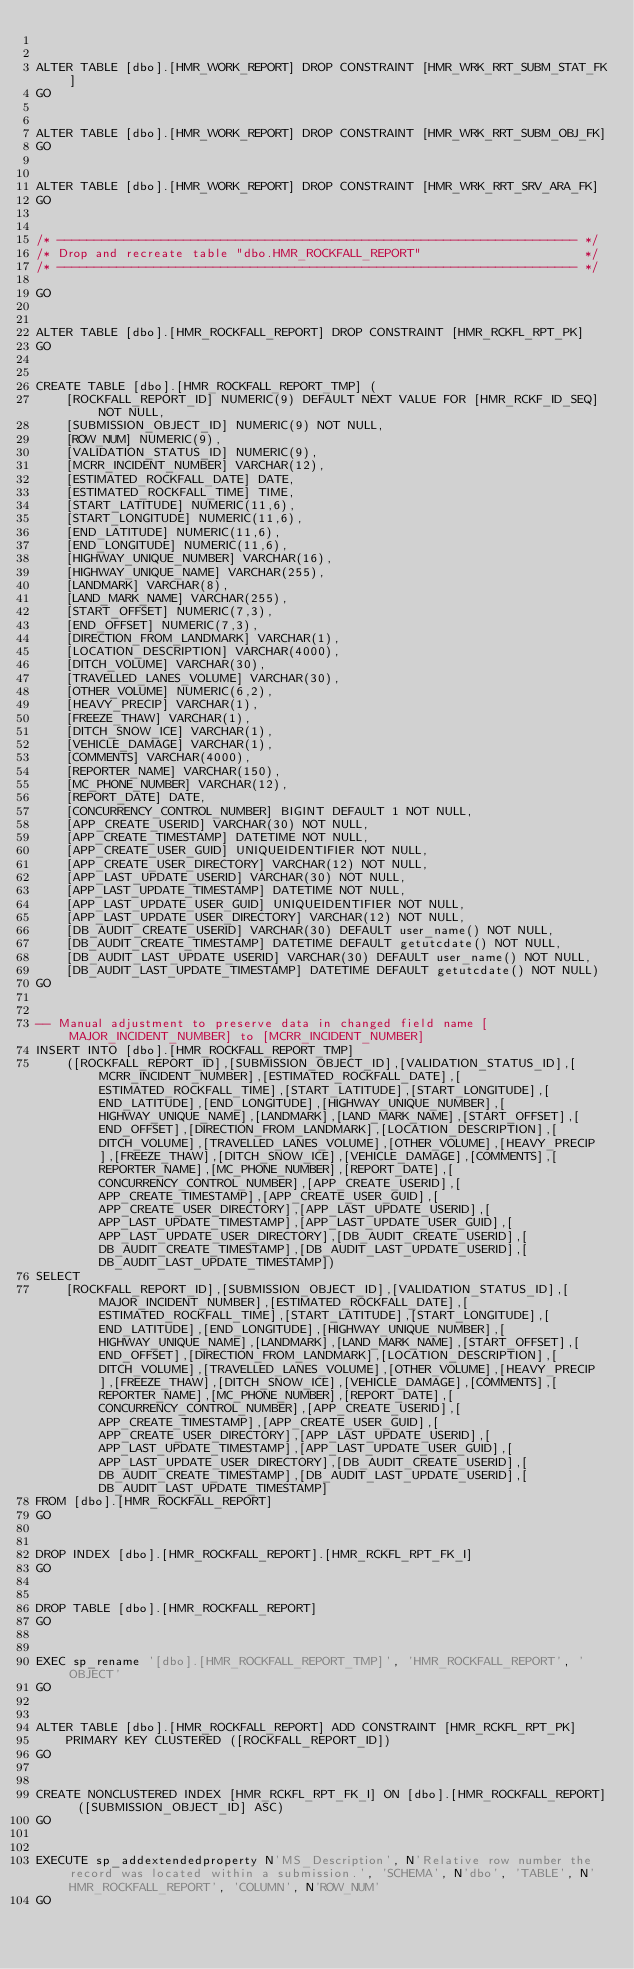<code> <loc_0><loc_0><loc_500><loc_500><_SQL_>

ALTER TABLE [dbo].[HMR_WORK_REPORT] DROP CONSTRAINT [HMR_WRK_RRT_SUBM_STAT_FK]
GO


ALTER TABLE [dbo].[HMR_WORK_REPORT] DROP CONSTRAINT [HMR_WRK_RRT_SUBM_OBJ_FK]
GO


ALTER TABLE [dbo].[HMR_WORK_REPORT] DROP CONSTRAINT [HMR_WRK_RRT_SRV_ARA_FK]
GO


/* ---------------------------------------------------------------------- */
/* Drop and recreate table "dbo.HMR_ROCKFALL_REPORT"                      */
/* ---------------------------------------------------------------------- */

GO


ALTER TABLE [dbo].[HMR_ROCKFALL_REPORT] DROP CONSTRAINT [HMR_RCKFL_RPT_PK]
GO


CREATE TABLE [dbo].[HMR_ROCKFALL_REPORT_TMP] (
    [ROCKFALL_REPORT_ID] NUMERIC(9) DEFAULT NEXT VALUE FOR [HMR_RCKF_ID_SEQ] NOT NULL,
    [SUBMISSION_OBJECT_ID] NUMERIC(9) NOT NULL,
    [ROW_NUM] NUMERIC(9),
    [VALIDATION_STATUS_ID] NUMERIC(9),
    [MCRR_INCIDENT_NUMBER] VARCHAR(12),
    [ESTIMATED_ROCKFALL_DATE] DATE,
    [ESTIMATED_ROCKFALL_TIME] TIME,
    [START_LATITUDE] NUMERIC(11,6),
    [START_LONGITUDE] NUMERIC(11,6),
    [END_LATITUDE] NUMERIC(11,6),
    [END_LONGITUDE] NUMERIC(11,6),
    [HIGHWAY_UNIQUE_NUMBER] VARCHAR(16),
    [HIGHWAY_UNIQUE_NAME] VARCHAR(255),
    [LANDMARK] VARCHAR(8),
    [LAND_MARK_NAME] VARCHAR(255),
    [START_OFFSET] NUMERIC(7,3),
    [END_OFFSET] NUMERIC(7,3),
    [DIRECTION_FROM_LANDMARK] VARCHAR(1),
    [LOCATION_DESCRIPTION] VARCHAR(4000),
    [DITCH_VOLUME] VARCHAR(30),
    [TRAVELLED_LANES_VOLUME] VARCHAR(30),
    [OTHER_VOLUME] NUMERIC(6,2),
    [HEAVY_PRECIP] VARCHAR(1),
    [FREEZE_THAW] VARCHAR(1),
    [DITCH_SNOW_ICE] VARCHAR(1),
    [VEHICLE_DAMAGE] VARCHAR(1),
    [COMMENTS] VARCHAR(4000),
    [REPORTER_NAME] VARCHAR(150),
    [MC_PHONE_NUMBER] VARCHAR(12),
    [REPORT_DATE] DATE,
    [CONCURRENCY_CONTROL_NUMBER] BIGINT DEFAULT 1 NOT NULL,
    [APP_CREATE_USERID] VARCHAR(30) NOT NULL,
    [APP_CREATE_TIMESTAMP] DATETIME NOT NULL,
    [APP_CREATE_USER_GUID] UNIQUEIDENTIFIER NOT NULL,
    [APP_CREATE_USER_DIRECTORY] VARCHAR(12) NOT NULL,
    [APP_LAST_UPDATE_USERID] VARCHAR(30) NOT NULL,
    [APP_LAST_UPDATE_TIMESTAMP] DATETIME NOT NULL,
    [APP_LAST_UPDATE_USER_GUID] UNIQUEIDENTIFIER NOT NULL,
    [APP_LAST_UPDATE_USER_DIRECTORY] VARCHAR(12) NOT NULL,
    [DB_AUDIT_CREATE_USERID] VARCHAR(30) DEFAULT user_name() NOT NULL,
    [DB_AUDIT_CREATE_TIMESTAMP] DATETIME DEFAULT getutcdate() NOT NULL,
    [DB_AUDIT_LAST_UPDATE_USERID] VARCHAR(30) DEFAULT user_name() NOT NULL,
    [DB_AUDIT_LAST_UPDATE_TIMESTAMP] DATETIME DEFAULT getutcdate() NOT NULL)
GO


-- Manual adjustment to preserve data in changed field name [MAJOR_INCIDENT_NUMBER] to [MCRR_INCIDENT_NUMBER]
INSERT INTO [dbo].[HMR_ROCKFALL_REPORT_TMP]
    ([ROCKFALL_REPORT_ID],[SUBMISSION_OBJECT_ID],[VALIDATION_STATUS_ID],[MCRR_INCIDENT_NUMBER],[ESTIMATED_ROCKFALL_DATE],[ESTIMATED_ROCKFALL_TIME],[START_LATITUDE],[START_LONGITUDE],[END_LATITUDE],[END_LONGITUDE],[HIGHWAY_UNIQUE_NUMBER],[HIGHWAY_UNIQUE_NAME],[LANDMARK],[LAND_MARK_NAME],[START_OFFSET],[END_OFFSET],[DIRECTION_FROM_LANDMARK],[LOCATION_DESCRIPTION],[DITCH_VOLUME],[TRAVELLED_LANES_VOLUME],[OTHER_VOLUME],[HEAVY_PRECIP],[FREEZE_THAW],[DITCH_SNOW_ICE],[VEHICLE_DAMAGE],[COMMENTS],[REPORTER_NAME],[MC_PHONE_NUMBER],[REPORT_DATE],[CONCURRENCY_CONTROL_NUMBER],[APP_CREATE_USERID],[APP_CREATE_TIMESTAMP],[APP_CREATE_USER_GUID],[APP_CREATE_USER_DIRECTORY],[APP_LAST_UPDATE_USERID],[APP_LAST_UPDATE_TIMESTAMP],[APP_LAST_UPDATE_USER_GUID],[APP_LAST_UPDATE_USER_DIRECTORY],[DB_AUDIT_CREATE_USERID],[DB_AUDIT_CREATE_TIMESTAMP],[DB_AUDIT_LAST_UPDATE_USERID],[DB_AUDIT_LAST_UPDATE_TIMESTAMP])
SELECT
    [ROCKFALL_REPORT_ID],[SUBMISSION_OBJECT_ID],[VALIDATION_STATUS_ID],[MAJOR_INCIDENT_NUMBER],[ESTIMATED_ROCKFALL_DATE],[ESTIMATED_ROCKFALL_TIME],[START_LATITUDE],[START_LONGITUDE],[END_LATITUDE],[END_LONGITUDE],[HIGHWAY_UNIQUE_NUMBER],[HIGHWAY_UNIQUE_NAME],[LANDMARK],[LAND_MARK_NAME],[START_OFFSET],[END_OFFSET],[DIRECTION_FROM_LANDMARK],[LOCATION_DESCRIPTION],[DITCH_VOLUME],[TRAVELLED_LANES_VOLUME],[OTHER_VOLUME],[HEAVY_PRECIP],[FREEZE_THAW],[DITCH_SNOW_ICE],[VEHICLE_DAMAGE],[COMMENTS],[REPORTER_NAME],[MC_PHONE_NUMBER],[REPORT_DATE],[CONCURRENCY_CONTROL_NUMBER],[APP_CREATE_USERID],[APP_CREATE_TIMESTAMP],[APP_CREATE_USER_GUID],[APP_CREATE_USER_DIRECTORY],[APP_LAST_UPDATE_USERID],[APP_LAST_UPDATE_TIMESTAMP],[APP_LAST_UPDATE_USER_GUID],[APP_LAST_UPDATE_USER_DIRECTORY],[DB_AUDIT_CREATE_USERID],[DB_AUDIT_CREATE_TIMESTAMP],[DB_AUDIT_LAST_UPDATE_USERID],[DB_AUDIT_LAST_UPDATE_TIMESTAMP]
FROM [dbo].[HMR_ROCKFALL_REPORT]
GO


DROP INDEX [dbo].[HMR_ROCKFALL_REPORT].[HMR_RCKFL_RPT_FK_I]
GO


DROP TABLE [dbo].[HMR_ROCKFALL_REPORT]
GO


EXEC sp_rename '[dbo].[HMR_ROCKFALL_REPORT_TMP]', 'HMR_ROCKFALL_REPORT', 'OBJECT'
GO


ALTER TABLE [dbo].[HMR_ROCKFALL_REPORT] ADD CONSTRAINT [HMR_RCKFL_RPT_PK] 
    PRIMARY KEY CLUSTERED ([ROCKFALL_REPORT_ID])
GO


CREATE NONCLUSTERED INDEX [HMR_RCKFL_RPT_FK_I] ON [dbo].[HMR_ROCKFALL_REPORT] ([SUBMISSION_OBJECT_ID] ASC)
GO


EXECUTE sp_addextendedproperty N'MS_Description', N'Relative row number the record was located within a submission.', 'SCHEMA', N'dbo', 'TABLE', N'HMR_ROCKFALL_REPORT', 'COLUMN', N'ROW_NUM'
GO

</code> 